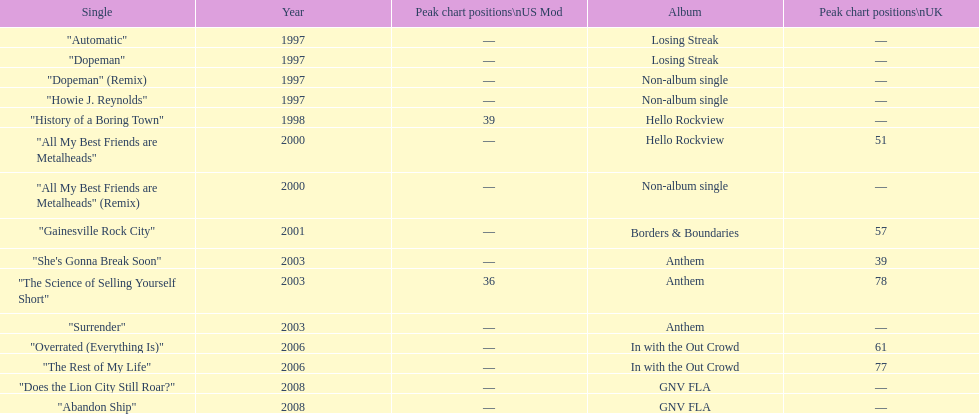In which album was the single "automatic" present? Losing Streak. 